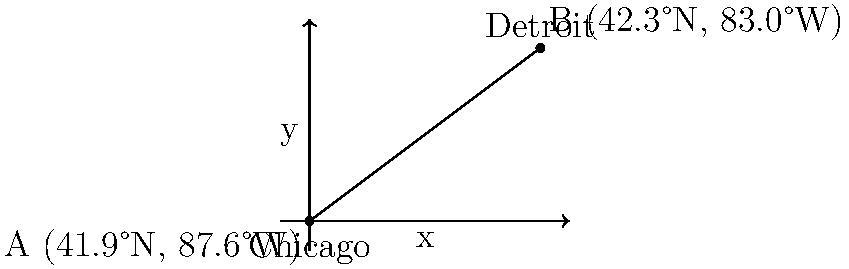Two Polish immigrant communities are located in Chicago (41.9°N, 87.6°W) and Detroit (42.3°N, 83.0°W). Using the Earth's radius as 6,371 km and assuming a flat surface for this calculation, determine the approximate distance between these two communities. To solve this problem, we'll use the Haversine formula, which is commonly used to calculate distances on a sphere. Here's the step-by-step solution:

1) Convert latitudes and longitudes from degrees to radians:
   $\text{Chicago}: \phi_1 = 41.9° \times \frac{\pi}{180} = 0.7313$ rad, $\lambda_1 = -87.6° \times \frac{\pi}{180} = -1.5290$ rad
   $\text{Detroit}: \phi_2 = 42.3° \times \frac{\pi}{180} = 0.7383$ rad, $\lambda_2 = -83.0° \times \frac{\pi}{180} = -1.4486$ rad

2) Calculate the differences:
   $\Delta\phi = \phi_2 - \phi_1 = 0.7383 - 0.7313 = 0.0070$ rad
   $\Delta\lambda = \lambda_2 - \lambda_1 = -1.4486 - (-1.5290) = 0.0804$ rad

3) Apply the Haversine formula:
   $a = \sin^2(\frac{\Delta\phi}{2}) + \cos(\phi_1) \cos(\phi_2) \sin^2(\frac{\Delta\lambda}{2})$
   $a = \sin^2(0.0035) + \cos(0.7313) \cos(0.7383) \sin^2(0.0402)$
   $a = 0.0000305 + 0.7431 \times 0.7388 \times 0.0016097 = 0.001219$

4) Calculate the central angle:
   $c = 2 \times \arctan2(\sqrt{a}, \sqrt{1-a})$
   $c = 2 \times \arctan2(\sqrt{0.001219}, \sqrt{1-0.001219}) = 0.06983$ rad

5) Calculate the distance:
   $d = R \times c$, where $R$ is the Earth's radius (6,371 km)
   $d = 6371 \times 0.06983 = 444.73$ km

Therefore, the approximate distance between the two Polish immigrant communities is about 445 km.
Answer: 445 km 